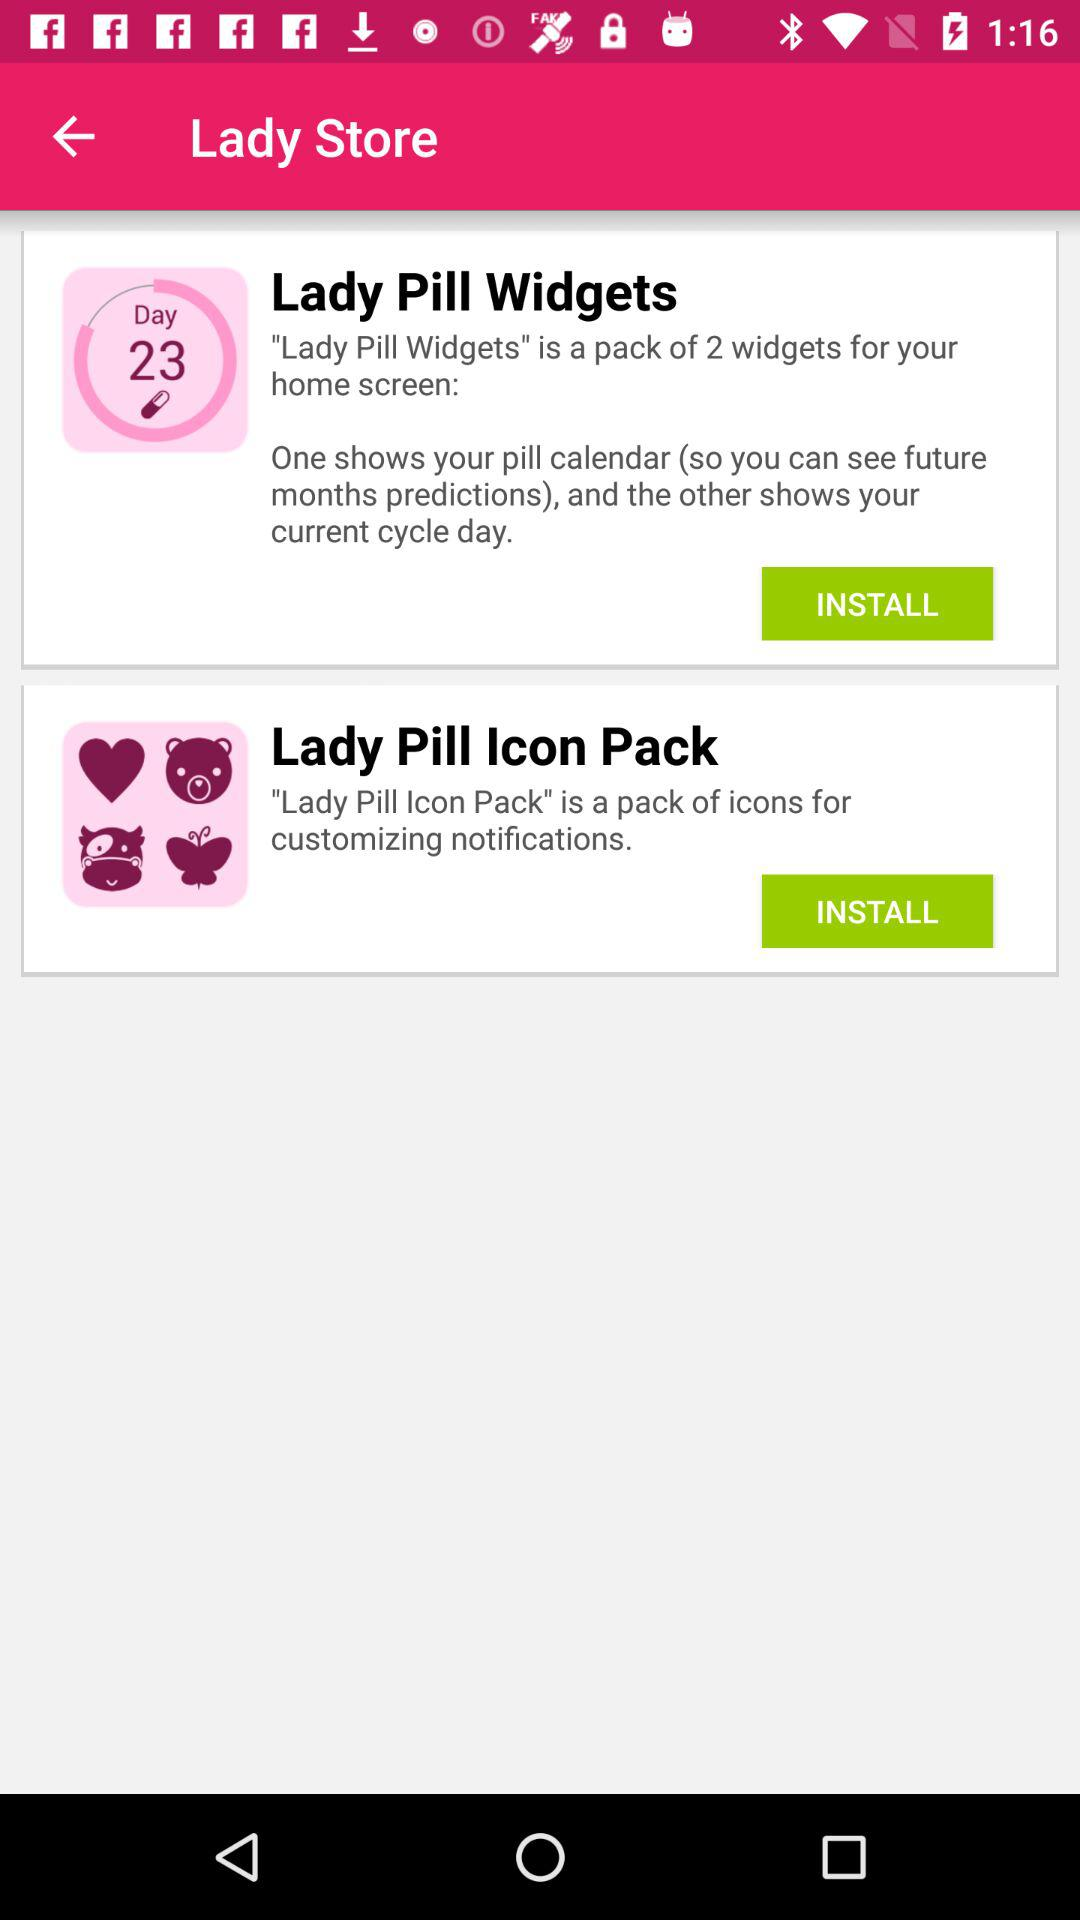How many items are in the store?
Answer the question using a single word or phrase. 2 